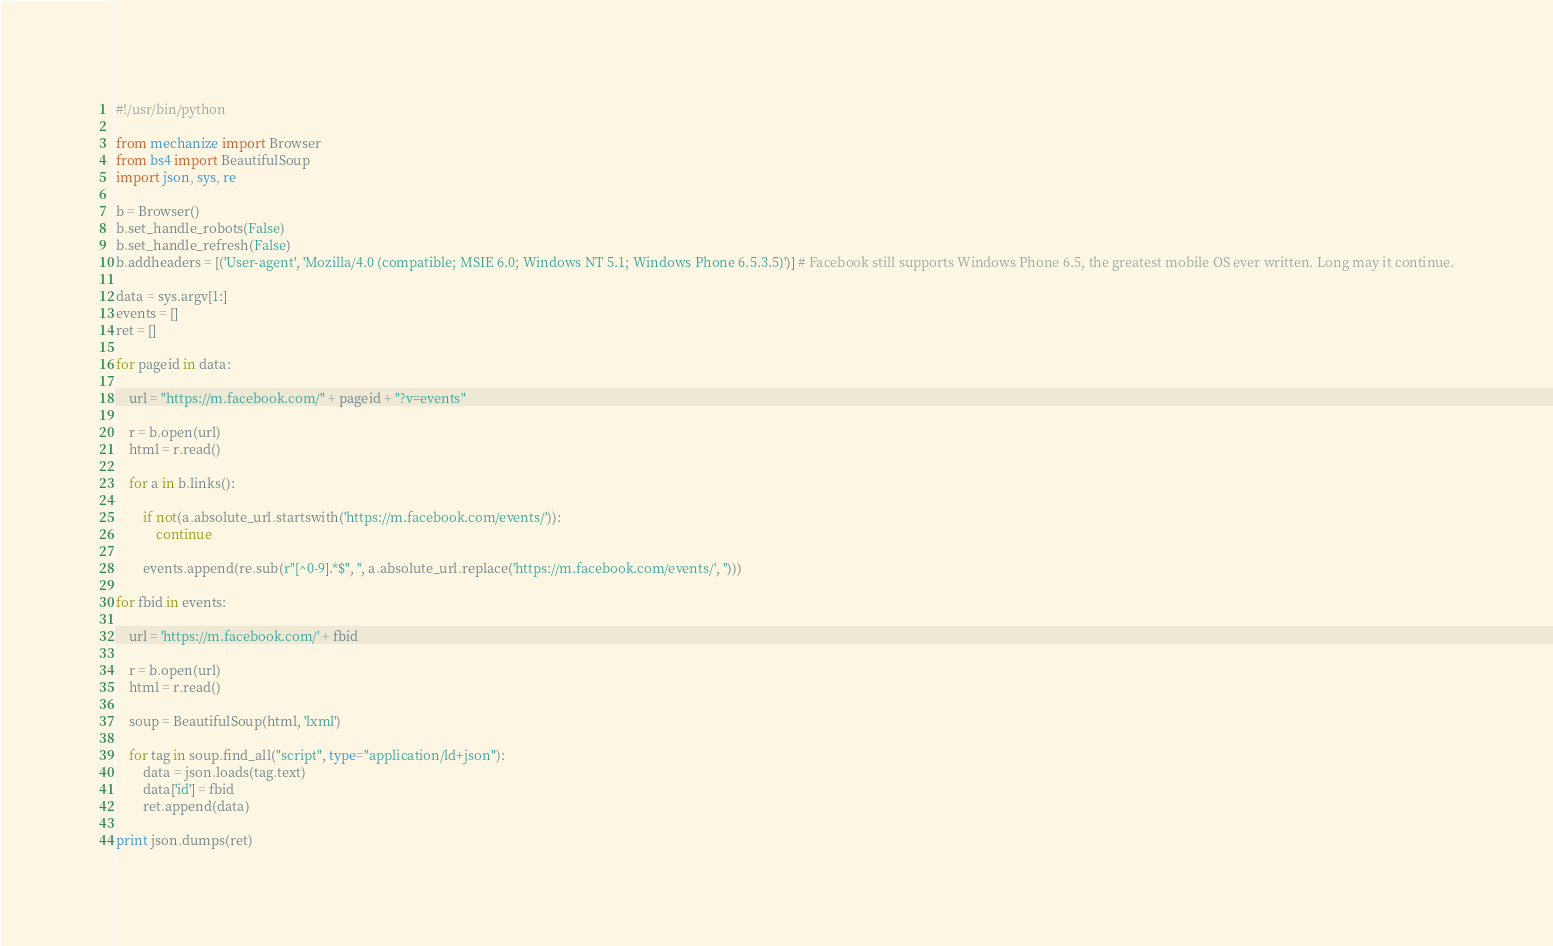Convert code to text. <code><loc_0><loc_0><loc_500><loc_500><_Python_>#!/usr/bin/python

from mechanize import Browser
from bs4 import BeautifulSoup
import json, sys, re

b = Browser()
b.set_handle_robots(False)
b.set_handle_refresh(False)
b.addheaders = [('User-agent', 'Mozilla/4.0 (compatible; MSIE 6.0; Windows NT 5.1; Windows Phone 6.5.3.5)')] # Facebook still supports Windows Phone 6.5, the greatest mobile OS ever written. Long may it continue.

data = sys.argv[1:]
events = []
ret = []

for pageid in data:

	url = "https://m.facebook.com/" + pageid + "?v=events"

	r = b.open(url)
	html = r.read()

	for a in b.links():

		if not(a.absolute_url.startswith('https://m.facebook.com/events/')):
			continue

		events.append(re.sub(r"[^0-9].*$", '', a.absolute_url.replace('https://m.facebook.com/events/', '')))

for fbid in events:

	url = 'https://m.facebook.com/' + fbid

	r = b.open(url)
	html = r.read()

	soup = BeautifulSoup(html, 'lxml')

	for tag in soup.find_all("script", type="application/ld+json"):
		data = json.loads(tag.text)
		data['id'] = fbid
		ret.append(data)

print json.dumps(ret)
</code> 